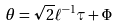<formula> <loc_0><loc_0><loc_500><loc_500>\theta = \sqrt { 2 } \ell ^ { - 1 } \tau + \Phi</formula> 